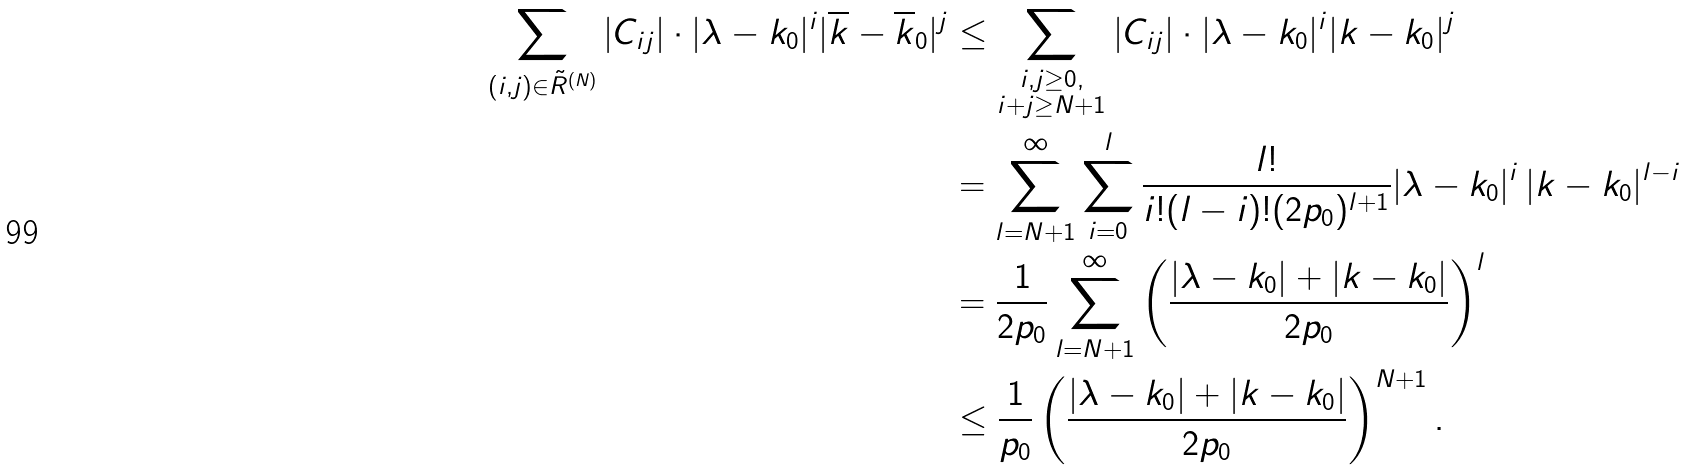<formula> <loc_0><loc_0><loc_500><loc_500>\sum _ { ( i , j ) \in \tilde { R } ^ { ( N ) } } | C _ { i j } | \cdot | \lambda - k _ { 0 } | ^ { i } | \overline { k } - \overline { k } _ { 0 } | ^ { j } & \leq \sum _ { \substack { i , j \geq 0 , \\ i + j \geq N + 1 } } | C _ { i j } | \cdot | \lambda - k _ { 0 } | ^ { i } | k - k _ { 0 } | ^ { j } \\ & = \sum ^ { \infty } _ { l = N + 1 } \sum _ { i = 0 } ^ { l } \frac { l ! } { i ! ( l - i ) ! ( 2 p _ { 0 } ) ^ { l + 1 } } | \lambda - k _ { 0 } | ^ { i } \, | k - k _ { 0 } | ^ { l - i } \\ & = \frac { 1 } { 2 p _ { 0 } } \sum _ { l = N + 1 } ^ { \infty } \left ( \frac { | \lambda - k _ { 0 } | + | k - k _ { 0 } | } { 2 p _ { 0 } } \right ) ^ { l } \\ & \leq \frac { 1 } { p _ { 0 } } \left ( \frac { | \lambda - k _ { 0 } | + | k - k _ { 0 } | } { 2 p _ { 0 } } \right ) ^ { N + 1 } .</formula> 